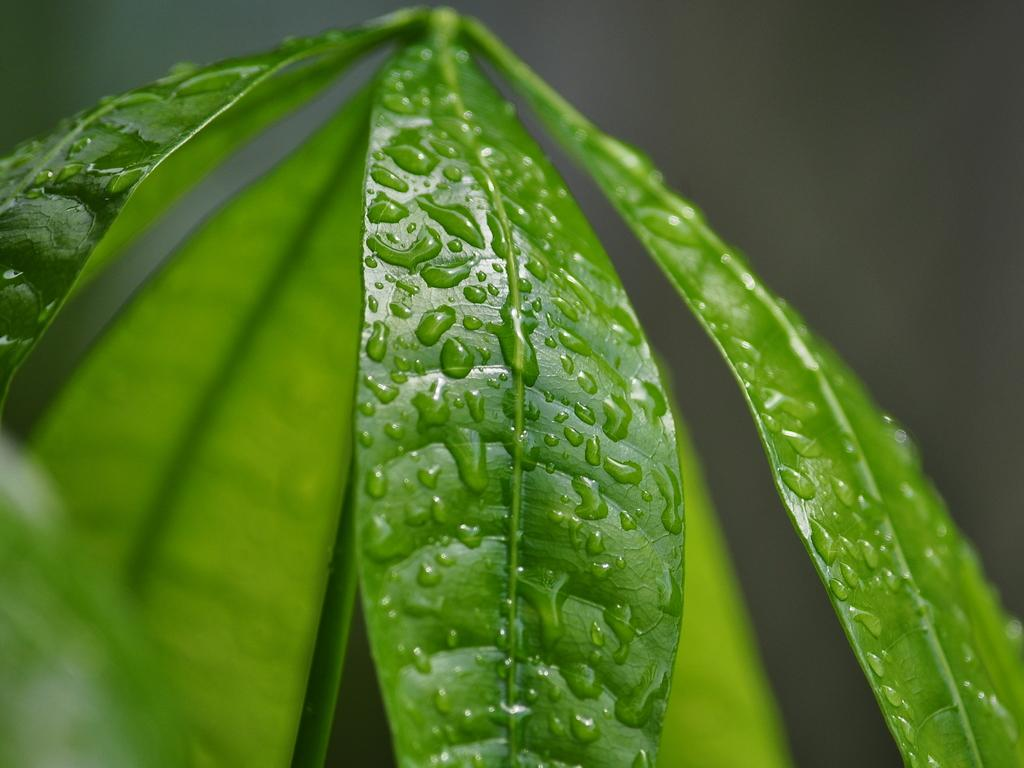What can be seen on the leaves in the foreground of the image? There are water droplets on the leaves in the foreground of the image. How would you describe the background of the image? The background of the image is blurred. What behavior can be observed in the person in the image? There is no person present in the image, so no behavior can be observed. What tendency is displayed by the water droplets in the image? The water droplets on the leaves do not display a tendency, as they are stationary in the image. 